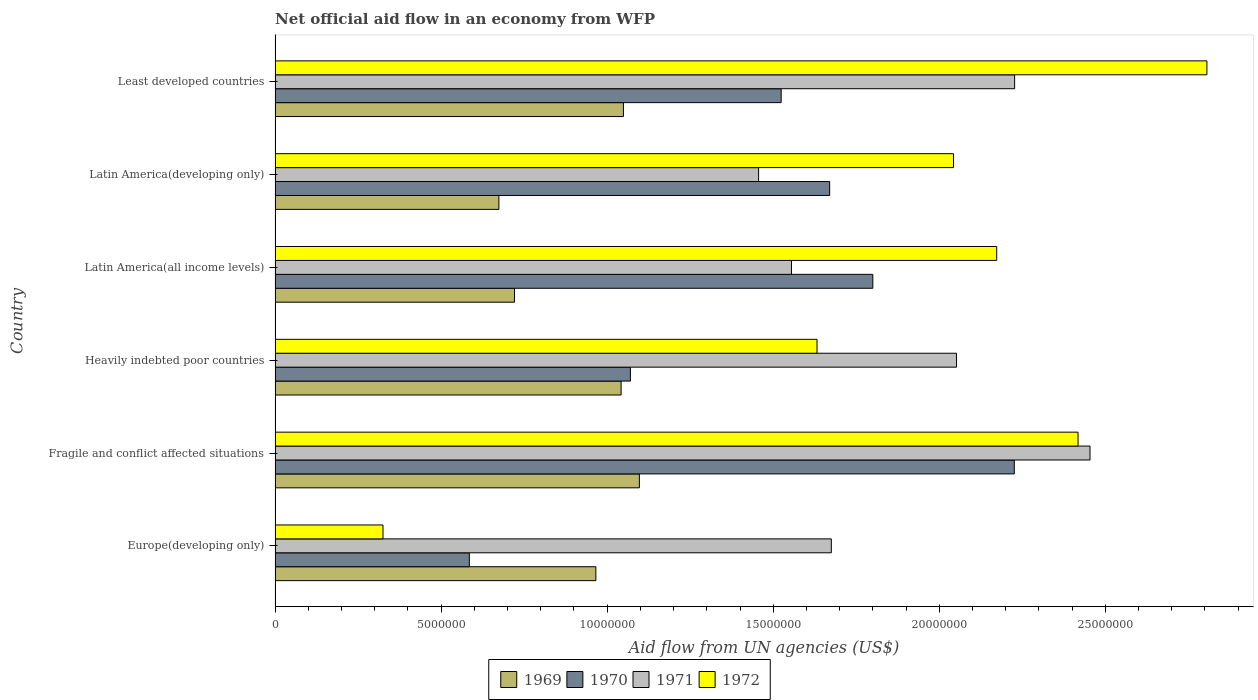How many different coloured bars are there?
Give a very brief answer. 4. Are the number of bars per tick equal to the number of legend labels?
Provide a short and direct response. Yes. How many bars are there on the 6th tick from the top?
Provide a short and direct response. 4. What is the label of the 5th group of bars from the top?
Your answer should be very brief. Fragile and conflict affected situations. What is the net official aid flow in 1970 in Latin America(all income levels)?
Keep it short and to the point. 1.80e+07. Across all countries, what is the maximum net official aid flow in 1970?
Keep it short and to the point. 2.23e+07. Across all countries, what is the minimum net official aid flow in 1971?
Ensure brevity in your answer.  1.46e+07. In which country was the net official aid flow in 1969 maximum?
Offer a very short reply. Fragile and conflict affected situations. In which country was the net official aid flow in 1969 minimum?
Ensure brevity in your answer.  Latin America(developing only). What is the total net official aid flow in 1971 in the graph?
Ensure brevity in your answer.  1.14e+08. What is the difference between the net official aid flow in 1971 in Latin America(developing only) and that in Least developed countries?
Offer a terse response. -7.71e+06. What is the difference between the net official aid flow in 1971 in Fragile and conflict affected situations and the net official aid flow in 1969 in Least developed countries?
Your answer should be very brief. 1.40e+07. What is the average net official aid flow in 1969 per country?
Keep it short and to the point. 9.25e+06. What is the difference between the net official aid flow in 1969 and net official aid flow in 1971 in Least developed countries?
Your response must be concise. -1.18e+07. What is the ratio of the net official aid flow in 1971 in Europe(developing only) to that in Least developed countries?
Ensure brevity in your answer.  0.75. Is the net official aid flow in 1972 in Heavily indebted poor countries less than that in Least developed countries?
Give a very brief answer. Yes. Is the difference between the net official aid flow in 1969 in Fragile and conflict affected situations and Latin America(developing only) greater than the difference between the net official aid flow in 1971 in Fragile and conflict affected situations and Latin America(developing only)?
Make the answer very short. No. What is the difference between the highest and the lowest net official aid flow in 1971?
Ensure brevity in your answer.  9.98e+06. In how many countries, is the net official aid flow in 1971 greater than the average net official aid flow in 1971 taken over all countries?
Offer a very short reply. 3. Is it the case that in every country, the sum of the net official aid flow in 1970 and net official aid flow in 1972 is greater than the sum of net official aid flow in 1969 and net official aid flow in 1971?
Your answer should be compact. No. Is it the case that in every country, the sum of the net official aid flow in 1971 and net official aid flow in 1969 is greater than the net official aid flow in 1970?
Keep it short and to the point. Yes. Are all the bars in the graph horizontal?
Ensure brevity in your answer.  Yes. Does the graph contain any zero values?
Offer a very short reply. No. Does the graph contain grids?
Your response must be concise. No. How many legend labels are there?
Your answer should be compact. 4. What is the title of the graph?
Your answer should be very brief. Net official aid flow in an economy from WFP. What is the label or title of the X-axis?
Your answer should be compact. Aid flow from UN agencies (US$). What is the Aid flow from UN agencies (US$) of 1969 in Europe(developing only)?
Your response must be concise. 9.66e+06. What is the Aid flow from UN agencies (US$) in 1970 in Europe(developing only)?
Ensure brevity in your answer.  5.85e+06. What is the Aid flow from UN agencies (US$) in 1971 in Europe(developing only)?
Your answer should be compact. 1.68e+07. What is the Aid flow from UN agencies (US$) of 1972 in Europe(developing only)?
Provide a short and direct response. 3.25e+06. What is the Aid flow from UN agencies (US$) of 1969 in Fragile and conflict affected situations?
Your answer should be compact. 1.10e+07. What is the Aid flow from UN agencies (US$) in 1970 in Fragile and conflict affected situations?
Provide a short and direct response. 2.23e+07. What is the Aid flow from UN agencies (US$) in 1971 in Fragile and conflict affected situations?
Provide a short and direct response. 2.45e+07. What is the Aid flow from UN agencies (US$) of 1972 in Fragile and conflict affected situations?
Make the answer very short. 2.42e+07. What is the Aid flow from UN agencies (US$) in 1969 in Heavily indebted poor countries?
Your response must be concise. 1.04e+07. What is the Aid flow from UN agencies (US$) in 1970 in Heavily indebted poor countries?
Provide a short and direct response. 1.07e+07. What is the Aid flow from UN agencies (US$) in 1971 in Heavily indebted poor countries?
Give a very brief answer. 2.05e+07. What is the Aid flow from UN agencies (US$) in 1972 in Heavily indebted poor countries?
Your response must be concise. 1.63e+07. What is the Aid flow from UN agencies (US$) of 1969 in Latin America(all income levels)?
Make the answer very short. 7.21e+06. What is the Aid flow from UN agencies (US$) of 1970 in Latin America(all income levels)?
Make the answer very short. 1.80e+07. What is the Aid flow from UN agencies (US$) in 1971 in Latin America(all income levels)?
Offer a very short reply. 1.56e+07. What is the Aid flow from UN agencies (US$) of 1972 in Latin America(all income levels)?
Your answer should be very brief. 2.17e+07. What is the Aid flow from UN agencies (US$) in 1969 in Latin America(developing only)?
Provide a succinct answer. 6.74e+06. What is the Aid flow from UN agencies (US$) in 1970 in Latin America(developing only)?
Make the answer very short. 1.67e+07. What is the Aid flow from UN agencies (US$) in 1971 in Latin America(developing only)?
Keep it short and to the point. 1.46e+07. What is the Aid flow from UN agencies (US$) of 1972 in Latin America(developing only)?
Ensure brevity in your answer.  2.04e+07. What is the Aid flow from UN agencies (US$) in 1969 in Least developed countries?
Offer a very short reply. 1.05e+07. What is the Aid flow from UN agencies (US$) of 1970 in Least developed countries?
Keep it short and to the point. 1.52e+07. What is the Aid flow from UN agencies (US$) in 1971 in Least developed countries?
Make the answer very short. 2.23e+07. What is the Aid flow from UN agencies (US$) in 1972 in Least developed countries?
Keep it short and to the point. 2.81e+07. Across all countries, what is the maximum Aid flow from UN agencies (US$) of 1969?
Ensure brevity in your answer.  1.10e+07. Across all countries, what is the maximum Aid flow from UN agencies (US$) of 1970?
Provide a succinct answer. 2.23e+07. Across all countries, what is the maximum Aid flow from UN agencies (US$) in 1971?
Offer a terse response. 2.45e+07. Across all countries, what is the maximum Aid flow from UN agencies (US$) of 1972?
Your answer should be compact. 2.81e+07. Across all countries, what is the minimum Aid flow from UN agencies (US$) in 1969?
Ensure brevity in your answer.  6.74e+06. Across all countries, what is the minimum Aid flow from UN agencies (US$) in 1970?
Ensure brevity in your answer.  5.85e+06. Across all countries, what is the minimum Aid flow from UN agencies (US$) of 1971?
Your answer should be compact. 1.46e+07. Across all countries, what is the minimum Aid flow from UN agencies (US$) of 1972?
Your response must be concise. 3.25e+06. What is the total Aid flow from UN agencies (US$) of 1969 in the graph?
Provide a short and direct response. 5.55e+07. What is the total Aid flow from UN agencies (US$) in 1970 in the graph?
Your answer should be very brief. 8.88e+07. What is the total Aid flow from UN agencies (US$) of 1971 in the graph?
Offer a very short reply. 1.14e+08. What is the total Aid flow from UN agencies (US$) in 1972 in the graph?
Provide a succinct answer. 1.14e+08. What is the difference between the Aid flow from UN agencies (US$) of 1969 in Europe(developing only) and that in Fragile and conflict affected situations?
Your response must be concise. -1.31e+06. What is the difference between the Aid flow from UN agencies (US$) of 1970 in Europe(developing only) and that in Fragile and conflict affected situations?
Offer a terse response. -1.64e+07. What is the difference between the Aid flow from UN agencies (US$) in 1971 in Europe(developing only) and that in Fragile and conflict affected situations?
Provide a succinct answer. -7.79e+06. What is the difference between the Aid flow from UN agencies (US$) in 1972 in Europe(developing only) and that in Fragile and conflict affected situations?
Provide a short and direct response. -2.09e+07. What is the difference between the Aid flow from UN agencies (US$) in 1969 in Europe(developing only) and that in Heavily indebted poor countries?
Make the answer very short. -7.60e+05. What is the difference between the Aid flow from UN agencies (US$) of 1970 in Europe(developing only) and that in Heavily indebted poor countries?
Provide a short and direct response. -4.85e+06. What is the difference between the Aid flow from UN agencies (US$) of 1971 in Europe(developing only) and that in Heavily indebted poor countries?
Offer a very short reply. -3.77e+06. What is the difference between the Aid flow from UN agencies (US$) of 1972 in Europe(developing only) and that in Heavily indebted poor countries?
Offer a very short reply. -1.31e+07. What is the difference between the Aid flow from UN agencies (US$) in 1969 in Europe(developing only) and that in Latin America(all income levels)?
Keep it short and to the point. 2.45e+06. What is the difference between the Aid flow from UN agencies (US$) in 1970 in Europe(developing only) and that in Latin America(all income levels)?
Keep it short and to the point. -1.22e+07. What is the difference between the Aid flow from UN agencies (US$) of 1971 in Europe(developing only) and that in Latin America(all income levels)?
Make the answer very short. 1.20e+06. What is the difference between the Aid flow from UN agencies (US$) of 1972 in Europe(developing only) and that in Latin America(all income levels)?
Make the answer very short. -1.85e+07. What is the difference between the Aid flow from UN agencies (US$) in 1969 in Europe(developing only) and that in Latin America(developing only)?
Make the answer very short. 2.92e+06. What is the difference between the Aid flow from UN agencies (US$) in 1970 in Europe(developing only) and that in Latin America(developing only)?
Provide a succinct answer. -1.08e+07. What is the difference between the Aid flow from UN agencies (US$) of 1971 in Europe(developing only) and that in Latin America(developing only)?
Your response must be concise. 2.19e+06. What is the difference between the Aid flow from UN agencies (US$) in 1972 in Europe(developing only) and that in Latin America(developing only)?
Give a very brief answer. -1.72e+07. What is the difference between the Aid flow from UN agencies (US$) of 1969 in Europe(developing only) and that in Least developed countries?
Your answer should be very brief. -8.30e+05. What is the difference between the Aid flow from UN agencies (US$) in 1970 in Europe(developing only) and that in Least developed countries?
Your answer should be very brief. -9.39e+06. What is the difference between the Aid flow from UN agencies (US$) of 1971 in Europe(developing only) and that in Least developed countries?
Make the answer very short. -5.52e+06. What is the difference between the Aid flow from UN agencies (US$) of 1972 in Europe(developing only) and that in Least developed countries?
Keep it short and to the point. -2.48e+07. What is the difference between the Aid flow from UN agencies (US$) in 1969 in Fragile and conflict affected situations and that in Heavily indebted poor countries?
Ensure brevity in your answer.  5.50e+05. What is the difference between the Aid flow from UN agencies (US$) of 1970 in Fragile and conflict affected situations and that in Heavily indebted poor countries?
Make the answer very short. 1.16e+07. What is the difference between the Aid flow from UN agencies (US$) in 1971 in Fragile and conflict affected situations and that in Heavily indebted poor countries?
Make the answer very short. 4.02e+06. What is the difference between the Aid flow from UN agencies (US$) of 1972 in Fragile and conflict affected situations and that in Heavily indebted poor countries?
Keep it short and to the point. 7.86e+06. What is the difference between the Aid flow from UN agencies (US$) in 1969 in Fragile and conflict affected situations and that in Latin America(all income levels)?
Make the answer very short. 3.76e+06. What is the difference between the Aid flow from UN agencies (US$) of 1970 in Fragile and conflict affected situations and that in Latin America(all income levels)?
Your answer should be compact. 4.26e+06. What is the difference between the Aid flow from UN agencies (US$) of 1971 in Fragile and conflict affected situations and that in Latin America(all income levels)?
Give a very brief answer. 8.99e+06. What is the difference between the Aid flow from UN agencies (US$) in 1972 in Fragile and conflict affected situations and that in Latin America(all income levels)?
Ensure brevity in your answer.  2.45e+06. What is the difference between the Aid flow from UN agencies (US$) in 1969 in Fragile and conflict affected situations and that in Latin America(developing only)?
Offer a terse response. 4.23e+06. What is the difference between the Aid flow from UN agencies (US$) of 1970 in Fragile and conflict affected situations and that in Latin America(developing only)?
Your response must be concise. 5.56e+06. What is the difference between the Aid flow from UN agencies (US$) of 1971 in Fragile and conflict affected situations and that in Latin America(developing only)?
Your response must be concise. 9.98e+06. What is the difference between the Aid flow from UN agencies (US$) of 1972 in Fragile and conflict affected situations and that in Latin America(developing only)?
Your answer should be compact. 3.75e+06. What is the difference between the Aid flow from UN agencies (US$) of 1969 in Fragile and conflict affected situations and that in Least developed countries?
Give a very brief answer. 4.80e+05. What is the difference between the Aid flow from UN agencies (US$) of 1970 in Fragile and conflict affected situations and that in Least developed countries?
Your answer should be compact. 7.02e+06. What is the difference between the Aid flow from UN agencies (US$) of 1971 in Fragile and conflict affected situations and that in Least developed countries?
Your response must be concise. 2.27e+06. What is the difference between the Aid flow from UN agencies (US$) in 1972 in Fragile and conflict affected situations and that in Least developed countries?
Ensure brevity in your answer.  -3.88e+06. What is the difference between the Aid flow from UN agencies (US$) in 1969 in Heavily indebted poor countries and that in Latin America(all income levels)?
Provide a succinct answer. 3.21e+06. What is the difference between the Aid flow from UN agencies (US$) in 1970 in Heavily indebted poor countries and that in Latin America(all income levels)?
Your answer should be very brief. -7.30e+06. What is the difference between the Aid flow from UN agencies (US$) of 1971 in Heavily indebted poor countries and that in Latin America(all income levels)?
Provide a succinct answer. 4.97e+06. What is the difference between the Aid flow from UN agencies (US$) of 1972 in Heavily indebted poor countries and that in Latin America(all income levels)?
Make the answer very short. -5.41e+06. What is the difference between the Aid flow from UN agencies (US$) of 1969 in Heavily indebted poor countries and that in Latin America(developing only)?
Provide a succinct answer. 3.68e+06. What is the difference between the Aid flow from UN agencies (US$) in 1970 in Heavily indebted poor countries and that in Latin America(developing only)?
Provide a short and direct response. -6.00e+06. What is the difference between the Aid flow from UN agencies (US$) in 1971 in Heavily indebted poor countries and that in Latin America(developing only)?
Your response must be concise. 5.96e+06. What is the difference between the Aid flow from UN agencies (US$) in 1972 in Heavily indebted poor countries and that in Latin America(developing only)?
Keep it short and to the point. -4.11e+06. What is the difference between the Aid flow from UN agencies (US$) of 1969 in Heavily indebted poor countries and that in Least developed countries?
Provide a short and direct response. -7.00e+04. What is the difference between the Aid flow from UN agencies (US$) of 1970 in Heavily indebted poor countries and that in Least developed countries?
Your answer should be very brief. -4.54e+06. What is the difference between the Aid flow from UN agencies (US$) in 1971 in Heavily indebted poor countries and that in Least developed countries?
Keep it short and to the point. -1.75e+06. What is the difference between the Aid flow from UN agencies (US$) of 1972 in Heavily indebted poor countries and that in Least developed countries?
Offer a terse response. -1.17e+07. What is the difference between the Aid flow from UN agencies (US$) of 1969 in Latin America(all income levels) and that in Latin America(developing only)?
Give a very brief answer. 4.70e+05. What is the difference between the Aid flow from UN agencies (US$) of 1970 in Latin America(all income levels) and that in Latin America(developing only)?
Your answer should be compact. 1.30e+06. What is the difference between the Aid flow from UN agencies (US$) in 1971 in Latin America(all income levels) and that in Latin America(developing only)?
Provide a succinct answer. 9.90e+05. What is the difference between the Aid flow from UN agencies (US$) in 1972 in Latin America(all income levels) and that in Latin America(developing only)?
Ensure brevity in your answer.  1.30e+06. What is the difference between the Aid flow from UN agencies (US$) in 1969 in Latin America(all income levels) and that in Least developed countries?
Keep it short and to the point. -3.28e+06. What is the difference between the Aid flow from UN agencies (US$) of 1970 in Latin America(all income levels) and that in Least developed countries?
Keep it short and to the point. 2.76e+06. What is the difference between the Aid flow from UN agencies (US$) of 1971 in Latin America(all income levels) and that in Least developed countries?
Offer a terse response. -6.72e+06. What is the difference between the Aid flow from UN agencies (US$) of 1972 in Latin America(all income levels) and that in Least developed countries?
Your answer should be very brief. -6.33e+06. What is the difference between the Aid flow from UN agencies (US$) in 1969 in Latin America(developing only) and that in Least developed countries?
Make the answer very short. -3.75e+06. What is the difference between the Aid flow from UN agencies (US$) of 1970 in Latin America(developing only) and that in Least developed countries?
Ensure brevity in your answer.  1.46e+06. What is the difference between the Aid flow from UN agencies (US$) in 1971 in Latin America(developing only) and that in Least developed countries?
Give a very brief answer. -7.71e+06. What is the difference between the Aid flow from UN agencies (US$) in 1972 in Latin America(developing only) and that in Least developed countries?
Give a very brief answer. -7.63e+06. What is the difference between the Aid flow from UN agencies (US$) in 1969 in Europe(developing only) and the Aid flow from UN agencies (US$) in 1970 in Fragile and conflict affected situations?
Provide a short and direct response. -1.26e+07. What is the difference between the Aid flow from UN agencies (US$) in 1969 in Europe(developing only) and the Aid flow from UN agencies (US$) in 1971 in Fragile and conflict affected situations?
Your answer should be compact. -1.49e+07. What is the difference between the Aid flow from UN agencies (US$) of 1969 in Europe(developing only) and the Aid flow from UN agencies (US$) of 1972 in Fragile and conflict affected situations?
Keep it short and to the point. -1.45e+07. What is the difference between the Aid flow from UN agencies (US$) in 1970 in Europe(developing only) and the Aid flow from UN agencies (US$) in 1971 in Fragile and conflict affected situations?
Provide a succinct answer. -1.87e+07. What is the difference between the Aid flow from UN agencies (US$) in 1970 in Europe(developing only) and the Aid flow from UN agencies (US$) in 1972 in Fragile and conflict affected situations?
Keep it short and to the point. -1.83e+07. What is the difference between the Aid flow from UN agencies (US$) in 1971 in Europe(developing only) and the Aid flow from UN agencies (US$) in 1972 in Fragile and conflict affected situations?
Keep it short and to the point. -7.43e+06. What is the difference between the Aid flow from UN agencies (US$) of 1969 in Europe(developing only) and the Aid flow from UN agencies (US$) of 1970 in Heavily indebted poor countries?
Keep it short and to the point. -1.04e+06. What is the difference between the Aid flow from UN agencies (US$) in 1969 in Europe(developing only) and the Aid flow from UN agencies (US$) in 1971 in Heavily indebted poor countries?
Provide a succinct answer. -1.09e+07. What is the difference between the Aid flow from UN agencies (US$) of 1969 in Europe(developing only) and the Aid flow from UN agencies (US$) of 1972 in Heavily indebted poor countries?
Offer a terse response. -6.66e+06. What is the difference between the Aid flow from UN agencies (US$) in 1970 in Europe(developing only) and the Aid flow from UN agencies (US$) in 1971 in Heavily indebted poor countries?
Keep it short and to the point. -1.47e+07. What is the difference between the Aid flow from UN agencies (US$) of 1970 in Europe(developing only) and the Aid flow from UN agencies (US$) of 1972 in Heavily indebted poor countries?
Provide a short and direct response. -1.05e+07. What is the difference between the Aid flow from UN agencies (US$) of 1969 in Europe(developing only) and the Aid flow from UN agencies (US$) of 1970 in Latin America(all income levels)?
Ensure brevity in your answer.  -8.34e+06. What is the difference between the Aid flow from UN agencies (US$) of 1969 in Europe(developing only) and the Aid flow from UN agencies (US$) of 1971 in Latin America(all income levels)?
Offer a very short reply. -5.89e+06. What is the difference between the Aid flow from UN agencies (US$) in 1969 in Europe(developing only) and the Aid flow from UN agencies (US$) in 1972 in Latin America(all income levels)?
Offer a very short reply. -1.21e+07. What is the difference between the Aid flow from UN agencies (US$) in 1970 in Europe(developing only) and the Aid flow from UN agencies (US$) in 1971 in Latin America(all income levels)?
Provide a succinct answer. -9.70e+06. What is the difference between the Aid flow from UN agencies (US$) in 1970 in Europe(developing only) and the Aid flow from UN agencies (US$) in 1972 in Latin America(all income levels)?
Provide a short and direct response. -1.59e+07. What is the difference between the Aid flow from UN agencies (US$) of 1971 in Europe(developing only) and the Aid flow from UN agencies (US$) of 1972 in Latin America(all income levels)?
Your answer should be very brief. -4.98e+06. What is the difference between the Aid flow from UN agencies (US$) of 1969 in Europe(developing only) and the Aid flow from UN agencies (US$) of 1970 in Latin America(developing only)?
Provide a succinct answer. -7.04e+06. What is the difference between the Aid flow from UN agencies (US$) of 1969 in Europe(developing only) and the Aid flow from UN agencies (US$) of 1971 in Latin America(developing only)?
Offer a very short reply. -4.90e+06. What is the difference between the Aid flow from UN agencies (US$) in 1969 in Europe(developing only) and the Aid flow from UN agencies (US$) in 1972 in Latin America(developing only)?
Your answer should be compact. -1.08e+07. What is the difference between the Aid flow from UN agencies (US$) in 1970 in Europe(developing only) and the Aid flow from UN agencies (US$) in 1971 in Latin America(developing only)?
Your response must be concise. -8.71e+06. What is the difference between the Aid flow from UN agencies (US$) in 1970 in Europe(developing only) and the Aid flow from UN agencies (US$) in 1972 in Latin America(developing only)?
Offer a terse response. -1.46e+07. What is the difference between the Aid flow from UN agencies (US$) of 1971 in Europe(developing only) and the Aid flow from UN agencies (US$) of 1972 in Latin America(developing only)?
Your answer should be compact. -3.68e+06. What is the difference between the Aid flow from UN agencies (US$) in 1969 in Europe(developing only) and the Aid flow from UN agencies (US$) in 1970 in Least developed countries?
Your answer should be very brief. -5.58e+06. What is the difference between the Aid flow from UN agencies (US$) of 1969 in Europe(developing only) and the Aid flow from UN agencies (US$) of 1971 in Least developed countries?
Offer a terse response. -1.26e+07. What is the difference between the Aid flow from UN agencies (US$) in 1969 in Europe(developing only) and the Aid flow from UN agencies (US$) in 1972 in Least developed countries?
Your answer should be compact. -1.84e+07. What is the difference between the Aid flow from UN agencies (US$) in 1970 in Europe(developing only) and the Aid flow from UN agencies (US$) in 1971 in Least developed countries?
Provide a succinct answer. -1.64e+07. What is the difference between the Aid flow from UN agencies (US$) of 1970 in Europe(developing only) and the Aid flow from UN agencies (US$) of 1972 in Least developed countries?
Ensure brevity in your answer.  -2.22e+07. What is the difference between the Aid flow from UN agencies (US$) of 1971 in Europe(developing only) and the Aid flow from UN agencies (US$) of 1972 in Least developed countries?
Make the answer very short. -1.13e+07. What is the difference between the Aid flow from UN agencies (US$) of 1969 in Fragile and conflict affected situations and the Aid flow from UN agencies (US$) of 1970 in Heavily indebted poor countries?
Your answer should be compact. 2.70e+05. What is the difference between the Aid flow from UN agencies (US$) in 1969 in Fragile and conflict affected situations and the Aid flow from UN agencies (US$) in 1971 in Heavily indebted poor countries?
Your answer should be compact. -9.55e+06. What is the difference between the Aid flow from UN agencies (US$) of 1969 in Fragile and conflict affected situations and the Aid flow from UN agencies (US$) of 1972 in Heavily indebted poor countries?
Offer a terse response. -5.35e+06. What is the difference between the Aid flow from UN agencies (US$) in 1970 in Fragile and conflict affected situations and the Aid flow from UN agencies (US$) in 1971 in Heavily indebted poor countries?
Offer a terse response. 1.74e+06. What is the difference between the Aid flow from UN agencies (US$) in 1970 in Fragile and conflict affected situations and the Aid flow from UN agencies (US$) in 1972 in Heavily indebted poor countries?
Your answer should be compact. 5.94e+06. What is the difference between the Aid flow from UN agencies (US$) in 1971 in Fragile and conflict affected situations and the Aid flow from UN agencies (US$) in 1972 in Heavily indebted poor countries?
Your answer should be very brief. 8.22e+06. What is the difference between the Aid flow from UN agencies (US$) of 1969 in Fragile and conflict affected situations and the Aid flow from UN agencies (US$) of 1970 in Latin America(all income levels)?
Give a very brief answer. -7.03e+06. What is the difference between the Aid flow from UN agencies (US$) of 1969 in Fragile and conflict affected situations and the Aid flow from UN agencies (US$) of 1971 in Latin America(all income levels)?
Offer a very short reply. -4.58e+06. What is the difference between the Aid flow from UN agencies (US$) in 1969 in Fragile and conflict affected situations and the Aid flow from UN agencies (US$) in 1972 in Latin America(all income levels)?
Give a very brief answer. -1.08e+07. What is the difference between the Aid flow from UN agencies (US$) in 1970 in Fragile and conflict affected situations and the Aid flow from UN agencies (US$) in 1971 in Latin America(all income levels)?
Your answer should be very brief. 6.71e+06. What is the difference between the Aid flow from UN agencies (US$) of 1970 in Fragile and conflict affected situations and the Aid flow from UN agencies (US$) of 1972 in Latin America(all income levels)?
Provide a short and direct response. 5.30e+05. What is the difference between the Aid flow from UN agencies (US$) in 1971 in Fragile and conflict affected situations and the Aid flow from UN agencies (US$) in 1972 in Latin America(all income levels)?
Provide a short and direct response. 2.81e+06. What is the difference between the Aid flow from UN agencies (US$) in 1969 in Fragile and conflict affected situations and the Aid flow from UN agencies (US$) in 1970 in Latin America(developing only)?
Provide a short and direct response. -5.73e+06. What is the difference between the Aid flow from UN agencies (US$) in 1969 in Fragile and conflict affected situations and the Aid flow from UN agencies (US$) in 1971 in Latin America(developing only)?
Offer a very short reply. -3.59e+06. What is the difference between the Aid flow from UN agencies (US$) of 1969 in Fragile and conflict affected situations and the Aid flow from UN agencies (US$) of 1972 in Latin America(developing only)?
Your answer should be compact. -9.46e+06. What is the difference between the Aid flow from UN agencies (US$) of 1970 in Fragile and conflict affected situations and the Aid flow from UN agencies (US$) of 1971 in Latin America(developing only)?
Ensure brevity in your answer.  7.70e+06. What is the difference between the Aid flow from UN agencies (US$) in 1970 in Fragile and conflict affected situations and the Aid flow from UN agencies (US$) in 1972 in Latin America(developing only)?
Make the answer very short. 1.83e+06. What is the difference between the Aid flow from UN agencies (US$) in 1971 in Fragile and conflict affected situations and the Aid flow from UN agencies (US$) in 1972 in Latin America(developing only)?
Provide a short and direct response. 4.11e+06. What is the difference between the Aid flow from UN agencies (US$) in 1969 in Fragile and conflict affected situations and the Aid flow from UN agencies (US$) in 1970 in Least developed countries?
Provide a succinct answer. -4.27e+06. What is the difference between the Aid flow from UN agencies (US$) in 1969 in Fragile and conflict affected situations and the Aid flow from UN agencies (US$) in 1971 in Least developed countries?
Your response must be concise. -1.13e+07. What is the difference between the Aid flow from UN agencies (US$) of 1969 in Fragile and conflict affected situations and the Aid flow from UN agencies (US$) of 1972 in Least developed countries?
Your answer should be very brief. -1.71e+07. What is the difference between the Aid flow from UN agencies (US$) in 1970 in Fragile and conflict affected situations and the Aid flow from UN agencies (US$) in 1972 in Least developed countries?
Make the answer very short. -5.80e+06. What is the difference between the Aid flow from UN agencies (US$) of 1971 in Fragile and conflict affected situations and the Aid flow from UN agencies (US$) of 1972 in Least developed countries?
Provide a succinct answer. -3.52e+06. What is the difference between the Aid flow from UN agencies (US$) in 1969 in Heavily indebted poor countries and the Aid flow from UN agencies (US$) in 1970 in Latin America(all income levels)?
Provide a short and direct response. -7.58e+06. What is the difference between the Aid flow from UN agencies (US$) of 1969 in Heavily indebted poor countries and the Aid flow from UN agencies (US$) of 1971 in Latin America(all income levels)?
Ensure brevity in your answer.  -5.13e+06. What is the difference between the Aid flow from UN agencies (US$) in 1969 in Heavily indebted poor countries and the Aid flow from UN agencies (US$) in 1972 in Latin America(all income levels)?
Give a very brief answer. -1.13e+07. What is the difference between the Aid flow from UN agencies (US$) in 1970 in Heavily indebted poor countries and the Aid flow from UN agencies (US$) in 1971 in Latin America(all income levels)?
Give a very brief answer. -4.85e+06. What is the difference between the Aid flow from UN agencies (US$) in 1970 in Heavily indebted poor countries and the Aid flow from UN agencies (US$) in 1972 in Latin America(all income levels)?
Keep it short and to the point. -1.10e+07. What is the difference between the Aid flow from UN agencies (US$) in 1971 in Heavily indebted poor countries and the Aid flow from UN agencies (US$) in 1972 in Latin America(all income levels)?
Keep it short and to the point. -1.21e+06. What is the difference between the Aid flow from UN agencies (US$) in 1969 in Heavily indebted poor countries and the Aid flow from UN agencies (US$) in 1970 in Latin America(developing only)?
Offer a terse response. -6.28e+06. What is the difference between the Aid flow from UN agencies (US$) of 1969 in Heavily indebted poor countries and the Aid flow from UN agencies (US$) of 1971 in Latin America(developing only)?
Ensure brevity in your answer.  -4.14e+06. What is the difference between the Aid flow from UN agencies (US$) of 1969 in Heavily indebted poor countries and the Aid flow from UN agencies (US$) of 1972 in Latin America(developing only)?
Provide a short and direct response. -1.00e+07. What is the difference between the Aid flow from UN agencies (US$) in 1970 in Heavily indebted poor countries and the Aid flow from UN agencies (US$) in 1971 in Latin America(developing only)?
Give a very brief answer. -3.86e+06. What is the difference between the Aid flow from UN agencies (US$) of 1970 in Heavily indebted poor countries and the Aid flow from UN agencies (US$) of 1972 in Latin America(developing only)?
Provide a succinct answer. -9.73e+06. What is the difference between the Aid flow from UN agencies (US$) in 1971 in Heavily indebted poor countries and the Aid flow from UN agencies (US$) in 1972 in Latin America(developing only)?
Keep it short and to the point. 9.00e+04. What is the difference between the Aid flow from UN agencies (US$) of 1969 in Heavily indebted poor countries and the Aid flow from UN agencies (US$) of 1970 in Least developed countries?
Ensure brevity in your answer.  -4.82e+06. What is the difference between the Aid flow from UN agencies (US$) of 1969 in Heavily indebted poor countries and the Aid flow from UN agencies (US$) of 1971 in Least developed countries?
Keep it short and to the point. -1.18e+07. What is the difference between the Aid flow from UN agencies (US$) of 1969 in Heavily indebted poor countries and the Aid flow from UN agencies (US$) of 1972 in Least developed countries?
Your response must be concise. -1.76e+07. What is the difference between the Aid flow from UN agencies (US$) in 1970 in Heavily indebted poor countries and the Aid flow from UN agencies (US$) in 1971 in Least developed countries?
Give a very brief answer. -1.16e+07. What is the difference between the Aid flow from UN agencies (US$) in 1970 in Heavily indebted poor countries and the Aid flow from UN agencies (US$) in 1972 in Least developed countries?
Your answer should be compact. -1.74e+07. What is the difference between the Aid flow from UN agencies (US$) of 1971 in Heavily indebted poor countries and the Aid flow from UN agencies (US$) of 1972 in Least developed countries?
Provide a short and direct response. -7.54e+06. What is the difference between the Aid flow from UN agencies (US$) in 1969 in Latin America(all income levels) and the Aid flow from UN agencies (US$) in 1970 in Latin America(developing only)?
Keep it short and to the point. -9.49e+06. What is the difference between the Aid flow from UN agencies (US$) of 1969 in Latin America(all income levels) and the Aid flow from UN agencies (US$) of 1971 in Latin America(developing only)?
Keep it short and to the point. -7.35e+06. What is the difference between the Aid flow from UN agencies (US$) in 1969 in Latin America(all income levels) and the Aid flow from UN agencies (US$) in 1972 in Latin America(developing only)?
Give a very brief answer. -1.32e+07. What is the difference between the Aid flow from UN agencies (US$) in 1970 in Latin America(all income levels) and the Aid flow from UN agencies (US$) in 1971 in Latin America(developing only)?
Offer a very short reply. 3.44e+06. What is the difference between the Aid flow from UN agencies (US$) of 1970 in Latin America(all income levels) and the Aid flow from UN agencies (US$) of 1972 in Latin America(developing only)?
Offer a terse response. -2.43e+06. What is the difference between the Aid flow from UN agencies (US$) of 1971 in Latin America(all income levels) and the Aid flow from UN agencies (US$) of 1972 in Latin America(developing only)?
Your answer should be very brief. -4.88e+06. What is the difference between the Aid flow from UN agencies (US$) in 1969 in Latin America(all income levels) and the Aid flow from UN agencies (US$) in 1970 in Least developed countries?
Offer a terse response. -8.03e+06. What is the difference between the Aid flow from UN agencies (US$) in 1969 in Latin America(all income levels) and the Aid flow from UN agencies (US$) in 1971 in Least developed countries?
Your answer should be compact. -1.51e+07. What is the difference between the Aid flow from UN agencies (US$) of 1969 in Latin America(all income levels) and the Aid flow from UN agencies (US$) of 1972 in Least developed countries?
Provide a succinct answer. -2.08e+07. What is the difference between the Aid flow from UN agencies (US$) of 1970 in Latin America(all income levels) and the Aid flow from UN agencies (US$) of 1971 in Least developed countries?
Keep it short and to the point. -4.27e+06. What is the difference between the Aid flow from UN agencies (US$) of 1970 in Latin America(all income levels) and the Aid flow from UN agencies (US$) of 1972 in Least developed countries?
Provide a short and direct response. -1.01e+07. What is the difference between the Aid flow from UN agencies (US$) in 1971 in Latin America(all income levels) and the Aid flow from UN agencies (US$) in 1972 in Least developed countries?
Make the answer very short. -1.25e+07. What is the difference between the Aid flow from UN agencies (US$) in 1969 in Latin America(developing only) and the Aid flow from UN agencies (US$) in 1970 in Least developed countries?
Offer a very short reply. -8.50e+06. What is the difference between the Aid flow from UN agencies (US$) of 1969 in Latin America(developing only) and the Aid flow from UN agencies (US$) of 1971 in Least developed countries?
Provide a short and direct response. -1.55e+07. What is the difference between the Aid flow from UN agencies (US$) of 1969 in Latin America(developing only) and the Aid flow from UN agencies (US$) of 1972 in Least developed countries?
Your answer should be compact. -2.13e+07. What is the difference between the Aid flow from UN agencies (US$) of 1970 in Latin America(developing only) and the Aid flow from UN agencies (US$) of 1971 in Least developed countries?
Give a very brief answer. -5.57e+06. What is the difference between the Aid flow from UN agencies (US$) of 1970 in Latin America(developing only) and the Aid flow from UN agencies (US$) of 1972 in Least developed countries?
Make the answer very short. -1.14e+07. What is the difference between the Aid flow from UN agencies (US$) of 1971 in Latin America(developing only) and the Aid flow from UN agencies (US$) of 1972 in Least developed countries?
Your answer should be compact. -1.35e+07. What is the average Aid flow from UN agencies (US$) of 1969 per country?
Ensure brevity in your answer.  9.25e+06. What is the average Aid flow from UN agencies (US$) in 1970 per country?
Your answer should be compact. 1.48e+07. What is the average Aid flow from UN agencies (US$) of 1971 per country?
Give a very brief answer. 1.90e+07. What is the average Aid flow from UN agencies (US$) in 1972 per country?
Provide a short and direct response. 1.90e+07. What is the difference between the Aid flow from UN agencies (US$) in 1969 and Aid flow from UN agencies (US$) in 1970 in Europe(developing only)?
Provide a short and direct response. 3.81e+06. What is the difference between the Aid flow from UN agencies (US$) of 1969 and Aid flow from UN agencies (US$) of 1971 in Europe(developing only)?
Offer a very short reply. -7.09e+06. What is the difference between the Aid flow from UN agencies (US$) of 1969 and Aid flow from UN agencies (US$) of 1972 in Europe(developing only)?
Provide a succinct answer. 6.41e+06. What is the difference between the Aid flow from UN agencies (US$) of 1970 and Aid flow from UN agencies (US$) of 1971 in Europe(developing only)?
Ensure brevity in your answer.  -1.09e+07. What is the difference between the Aid flow from UN agencies (US$) in 1970 and Aid flow from UN agencies (US$) in 1972 in Europe(developing only)?
Your answer should be very brief. 2.60e+06. What is the difference between the Aid flow from UN agencies (US$) in 1971 and Aid flow from UN agencies (US$) in 1972 in Europe(developing only)?
Your answer should be compact. 1.35e+07. What is the difference between the Aid flow from UN agencies (US$) of 1969 and Aid flow from UN agencies (US$) of 1970 in Fragile and conflict affected situations?
Ensure brevity in your answer.  -1.13e+07. What is the difference between the Aid flow from UN agencies (US$) in 1969 and Aid flow from UN agencies (US$) in 1971 in Fragile and conflict affected situations?
Give a very brief answer. -1.36e+07. What is the difference between the Aid flow from UN agencies (US$) of 1969 and Aid flow from UN agencies (US$) of 1972 in Fragile and conflict affected situations?
Make the answer very short. -1.32e+07. What is the difference between the Aid flow from UN agencies (US$) of 1970 and Aid flow from UN agencies (US$) of 1971 in Fragile and conflict affected situations?
Offer a terse response. -2.28e+06. What is the difference between the Aid flow from UN agencies (US$) in 1970 and Aid flow from UN agencies (US$) in 1972 in Fragile and conflict affected situations?
Provide a short and direct response. -1.92e+06. What is the difference between the Aid flow from UN agencies (US$) in 1971 and Aid flow from UN agencies (US$) in 1972 in Fragile and conflict affected situations?
Make the answer very short. 3.60e+05. What is the difference between the Aid flow from UN agencies (US$) in 1969 and Aid flow from UN agencies (US$) in 1970 in Heavily indebted poor countries?
Your response must be concise. -2.80e+05. What is the difference between the Aid flow from UN agencies (US$) of 1969 and Aid flow from UN agencies (US$) of 1971 in Heavily indebted poor countries?
Make the answer very short. -1.01e+07. What is the difference between the Aid flow from UN agencies (US$) in 1969 and Aid flow from UN agencies (US$) in 1972 in Heavily indebted poor countries?
Offer a very short reply. -5.90e+06. What is the difference between the Aid flow from UN agencies (US$) of 1970 and Aid flow from UN agencies (US$) of 1971 in Heavily indebted poor countries?
Provide a short and direct response. -9.82e+06. What is the difference between the Aid flow from UN agencies (US$) of 1970 and Aid flow from UN agencies (US$) of 1972 in Heavily indebted poor countries?
Make the answer very short. -5.62e+06. What is the difference between the Aid flow from UN agencies (US$) in 1971 and Aid flow from UN agencies (US$) in 1972 in Heavily indebted poor countries?
Provide a short and direct response. 4.20e+06. What is the difference between the Aid flow from UN agencies (US$) of 1969 and Aid flow from UN agencies (US$) of 1970 in Latin America(all income levels)?
Provide a succinct answer. -1.08e+07. What is the difference between the Aid flow from UN agencies (US$) in 1969 and Aid flow from UN agencies (US$) in 1971 in Latin America(all income levels)?
Keep it short and to the point. -8.34e+06. What is the difference between the Aid flow from UN agencies (US$) in 1969 and Aid flow from UN agencies (US$) in 1972 in Latin America(all income levels)?
Give a very brief answer. -1.45e+07. What is the difference between the Aid flow from UN agencies (US$) of 1970 and Aid flow from UN agencies (US$) of 1971 in Latin America(all income levels)?
Your response must be concise. 2.45e+06. What is the difference between the Aid flow from UN agencies (US$) in 1970 and Aid flow from UN agencies (US$) in 1972 in Latin America(all income levels)?
Make the answer very short. -3.73e+06. What is the difference between the Aid flow from UN agencies (US$) in 1971 and Aid flow from UN agencies (US$) in 1972 in Latin America(all income levels)?
Provide a succinct answer. -6.18e+06. What is the difference between the Aid flow from UN agencies (US$) of 1969 and Aid flow from UN agencies (US$) of 1970 in Latin America(developing only)?
Offer a very short reply. -9.96e+06. What is the difference between the Aid flow from UN agencies (US$) of 1969 and Aid flow from UN agencies (US$) of 1971 in Latin America(developing only)?
Offer a terse response. -7.82e+06. What is the difference between the Aid flow from UN agencies (US$) in 1969 and Aid flow from UN agencies (US$) in 1972 in Latin America(developing only)?
Provide a short and direct response. -1.37e+07. What is the difference between the Aid flow from UN agencies (US$) in 1970 and Aid flow from UN agencies (US$) in 1971 in Latin America(developing only)?
Make the answer very short. 2.14e+06. What is the difference between the Aid flow from UN agencies (US$) in 1970 and Aid flow from UN agencies (US$) in 1972 in Latin America(developing only)?
Make the answer very short. -3.73e+06. What is the difference between the Aid flow from UN agencies (US$) of 1971 and Aid flow from UN agencies (US$) of 1972 in Latin America(developing only)?
Your answer should be compact. -5.87e+06. What is the difference between the Aid flow from UN agencies (US$) in 1969 and Aid flow from UN agencies (US$) in 1970 in Least developed countries?
Provide a short and direct response. -4.75e+06. What is the difference between the Aid flow from UN agencies (US$) in 1969 and Aid flow from UN agencies (US$) in 1971 in Least developed countries?
Keep it short and to the point. -1.18e+07. What is the difference between the Aid flow from UN agencies (US$) in 1969 and Aid flow from UN agencies (US$) in 1972 in Least developed countries?
Offer a terse response. -1.76e+07. What is the difference between the Aid flow from UN agencies (US$) of 1970 and Aid flow from UN agencies (US$) of 1971 in Least developed countries?
Your response must be concise. -7.03e+06. What is the difference between the Aid flow from UN agencies (US$) of 1970 and Aid flow from UN agencies (US$) of 1972 in Least developed countries?
Your answer should be very brief. -1.28e+07. What is the difference between the Aid flow from UN agencies (US$) of 1971 and Aid flow from UN agencies (US$) of 1972 in Least developed countries?
Your answer should be compact. -5.79e+06. What is the ratio of the Aid flow from UN agencies (US$) of 1969 in Europe(developing only) to that in Fragile and conflict affected situations?
Ensure brevity in your answer.  0.88. What is the ratio of the Aid flow from UN agencies (US$) of 1970 in Europe(developing only) to that in Fragile and conflict affected situations?
Your answer should be compact. 0.26. What is the ratio of the Aid flow from UN agencies (US$) of 1971 in Europe(developing only) to that in Fragile and conflict affected situations?
Offer a terse response. 0.68. What is the ratio of the Aid flow from UN agencies (US$) in 1972 in Europe(developing only) to that in Fragile and conflict affected situations?
Offer a very short reply. 0.13. What is the ratio of the Aid flow from UN agencies (US$) in 1969 in Europe(developing only) to that in Heavily indebted poor countries?
Give a very brief answer. 0.93. What is the ratio of the Aid flow from UN agencies (US$) in 1970 in Europe(developing only) to that in Heavily indebted poor countries?
Offer a terse response. 0.55. What is the ratio of the Aid flow from UN agencies (US$) in 1971 in Europe(developing only) to that in Heavily indebted poor countries?
Offer a terse response. 0.82. What is the ratio of the Aid flow from UN agencies (US$) of 1972 in Europe(developing only) to that in Heavily indebted poor countries?
Your response must be concise. 0.2. What is the ratio of the Aid flow from UN agencies (US$) in 1969 in Europe(developing only) to that in Latin America(all income levels)?
Provide a short and direct response. 1.34. What is the ratio of the Aid flow from UN agencies (US$) in 1970 in Europe(developing only) to that in Latin America(all income levels)?
Make the answer very short. 0.33. What is the ratio of the Aid flow from UN agencies (US$) of 1971 in Europe(developing only) to that in Latin America(all income levels)?
Your answer should be compact. 1.08. What is the ratio of the Aid flow from UN agencies (US$) in 1972 in Europe(developing only) to that in Latin America(all income levels)?
Your response must be concise. 0.15. What is the ratio of the Aid flow from UN agencies (US$) in 1969 in Europe(developing only) to that in Latin America(developing only)?
Provide a short and direct response. 1.43. What is the ratio of the Aid flow from UN agencies (US$) in 1970 in Europe(developing only) to that in Latin America(developing only)?
Ensure brevity in your answer.  0.35. What is the ratio of the Aid flow from UN agencies (US$) of 1971 in Europe(developing only) to that in Latin America(developing only)?
Offer a very short reply. 1.15. What is the ratio of the Aid flow from UN agencies (US$) of 1972 in Europe(developing only) to that in Latin America(developing only)?
Your answer should be very brief. 0.16. What is the ratio of the Aid flow from UN agencies (US$) of 1969 in Europe(developing only) to that in Least developed countries?
Provide a succinct answer. 0.92. What is the ratio of the Aid flow from UN agencies (US$) of 1970 in Europe(developing only) to that in Least developed countries?
Offer a terse response. 0.38. What is the ratio of the Aid flow from UN agencies (US$) of 1971 in Europe(developing only) to that in Least developed countries?
Make the answer very short. 0.75. What is the ratio of the Aid flow from UN agencies (US$) in 1972 in Europe(developing only) to that in Least developed countries?
Your answer should be compact. 0.12. What is the ratio of the Aid flow from UN agencies (US$) of 1969 in Fragile and conflict affected situations to that in Heavily indebted poor countries?
Your response must be concise. 1.05. What is the ratio of the Aid flow from UN agencies (US$) in 1970 in Fragile and conflict affected situations to that in Heavily indebted poor countries?
Offer a very short reply. 2.08. What is the ratio of the Aid flow from UN agencies (US$) of 1971 in Fragile and conflict affected situations to that in Heavily indebted poor countries?
Offer a very short reply. 1.2. What is the ratio of the Aid flow from UN agencies (US$) of 1972 in Fragile and conflict affected situations to that in Heavily indebted poor countries?
Give a very brief answer. 1.48. What is the ratio of the Aid flow from UN agencies (US$) of 1969 in Fragile and conflict affected situations to that in Latin America(all income levels)?
Your answer should be compact. 1.52. What is the ratio of the Aid flow from UN agencies (US$) in 1970 in Fragile and conflict affected situations to that in Latin America(all income levels)?
Provide a succinct answer. 1.24. What is the ratio of the Aid flow from UN agencies (US$) in 1971 in Fragile and conflict affected situations to that in Latin America(all income levels)?
Provide a succinct answer. 1.58. What is the ratio of the Aid flow from UN agencies (US$) of 1972 in Fragile and conflict affected situations to that in Latin America(all income levels)?
Your response must be concise. 1.11. What is the ratio of the Aid flow from UN agencies (US$) in 1969 in Fragile and conflict affected situations to that in Latin America(developing only)?
Make the answer very short. 1.63. What is the ratio of the Aid flow from UN agencies (US$) in 1970 in Fragile and conflict affected situations to that in Latin America(developing only)?
Ensure brevity in your answer.  1.33. What is the ratio of the Aid flow from UN agencies (US$) in 1971 in Fragile and conflict affected situations to that in Latin America(developing only)?
Give a very brief answer. 1.69. What is the ratio of the Aid flow from UN agencies (US$) in 1972 in Fragile and conflict affected situations to that in Latin America(developing only)?
Ensure brevity in your answer.  1.18. What is the ratio of the Aid flow from UN agencies (US$) in 1969 in Fragile and conflict affected situations to that in Least developed countries?
Your answer should be compact. 1.05. What is the ratio of the Aid flow from UN agencies (US$) in 1970 in Fragile and conflict affected situations to that in Least developed countries?
Offer a terse response. 1.46. What is the ratio of the Aid flow from UN agencies (US$) of 1971 in Fragile and conflict affected situations to that in Least developed countries?
Make the answer very short. 1.1. What is the ratio of the Aid flow from UN agencies (US$) in 1972 in Fragile and conflict affected situations to that in Least developed countries?
Offer a terse response. 0.86. What is the ratio of the Aid flow from UN agencies (US$) of 1969 in Heavily indebted poor countries to that in Latin America(all income levels)?
Your answer should be compact. 1.45. What is the ratio of the Aid flow from UN agencies (US$) in 1970 in Heavily indebted poor countries to that in Latin America(all income levels)?
Give a very brief answer. 0.59. What is the ratio of the Aid flow from UN agencies (US$) of 1971 in Heavily indebted poor countries to that in Latin America(all income levels)?
Ensure brevity in your answer.  1.32. What is the ratio of the Aid flow from UN agencies (US$) in 1972 in Heavily indebted poor countries to that in Latin America(all income levels)?
Provide a short and direct response. 0.75. What is the ratio of the Aid flow from UN agencies (US$) of 1969 in Heavily indebted poor countries to that in Latin America(developing only)?
Give a very brief answer. 1.55. What is the ratio of the Aid flow from UN agencies (US$) in 1970 in Heavily indebted poor countries to that in Latin America(developing only)?
Keep it short and to the point. 0.64. What is the ratio of the Aid flow from UN agencies (US$) in 1971 in Heavily indebted poor countries to that in Latin America(developing only)?
Offer a terse response. 1.41. What is the ratio of the Aid flow from UN agencies (US$) of 1972 in Heavily indebted poor countries to that in Latin America(developing only)?
Make the answer very short. 0.8. What is the ratio of the Aid flow from UN agencies (US$) of 1970 in Heavily indebted poor countries to that in Least developed countries?
Your response must be concise. 0.7. What is the ratio of the Aid flow from UN agencies (US$) of 1971 in Heavily indebted poor countries to that in Least developed countries?
Offer a very short reply. 0.92. What is the ratio of the Aid flow from UN agencies (US$) in 1972 in Heavily indebted poor countries to that in Least developed countries?
Your answer should be very brief. 0.58. What is the ratio of the Aid flow from UN agencies (US$) of 1969 in Latin America(all income levels) to that in Latin America(developing only)?
Provide a short and direct response. 1.07. What is the ratio of the Aid flow from UN agencies (US$) of 1970 in Latin America(all income levels) to that in Latin America(developing only)?
Keep it short and to the point. 1.08. What is the ratio of the Aid flow from UN agencies (US$) in 1971 in Latin America(all income levels) to that in Latin America(developing only)?
Make the answer very short. 1.07. What is the ratio of the Aid flow from UN agencies (US$) in 1972 in Latin America(all income levels) to that in Latin America(developing only)?
Make the answer very short. 1.06. What is the ratio of the Aid flow from UN agencies (US$) of 1969 in Latin America(all income levels) to that in Least developed countries?
Your answer should be compact. 0.69. What is the ratio of the Aid flow from UN agencies (US$) in 1970 in Latin America(all income levels) to that in Least developed countries?
Give a very brief answer. 1.18. What is the ratio of the Aid flow from UN agencies (US$) of 1971 in Latin America(all income levels) to that in Least developed countries?
Ensure brevity in your answer.  0.7. What is the ratio of the Aid flow from UN agencies (US$) in 1972 in Latin America(all income levels) to that in Least developed countries?
Provide a short and direct response. 0.77. What is the ratio of the Aid flow from UN agencies (US$) of 1969 in Latin America(developing only) to that in Least developed countries?
Keep it short and to the point. 0.64. What is the ratio of the Aid flow from UN agencies (US$) of 1970 in Latin America(developing only) to that in Least developed countries?
Offer a very short reply. 1.1. What is the ratio of the Aid flow from UN agencies (US$) of 1971 in Latin America(developing only) to that in Least developed countries?
Give a very brief answer. 0.65. What is the ratio of the Aid flow from UN agencies (US$) in 1972 in Latin America(developing only) to that in Least developed countries?
Make the answer very short. 0.73. What is the difference between the highest and the second highest Aid flow from UN agencies (US$) of 1970?
Ensure brevity in your answer.  4.26e+06. What is the difference between the highest and the second highest Aid flow from UN agencies (US$) in 1971?
Keep it short and to the point. 2.27e+06. What is the difference between the highest and the second highest Aid flow from UN agencies (US$) in 1972?
Your answer should be compact. 3.88e+06. What is the difference between the highest and the lowest Aid flow from UN agencies (US$) in 1969?
Provide a succinct answer. 4.23e+06. What is the difference between the highest and the lowest Aid flow from UN agencies (US$) in 1970?
Give a very brief answer. 1.64e+07. What is the difference between the highest and the lowest Aid flow from UN agencies (US$) of 1971?
Your answer should be compact. 9.98e+06. What is the difference between the highest and the lowest Aid flow from UN agencies (US$) of 1972?
Your answer should be very brief. 2.48e+07. 